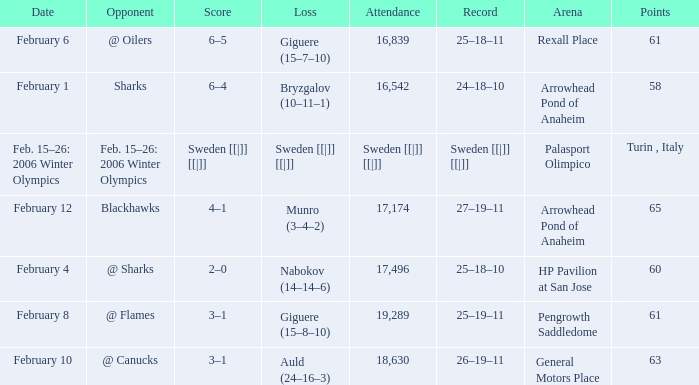What is the Arena when there were 65 points? Arrowhead Pond of Anaheim. 